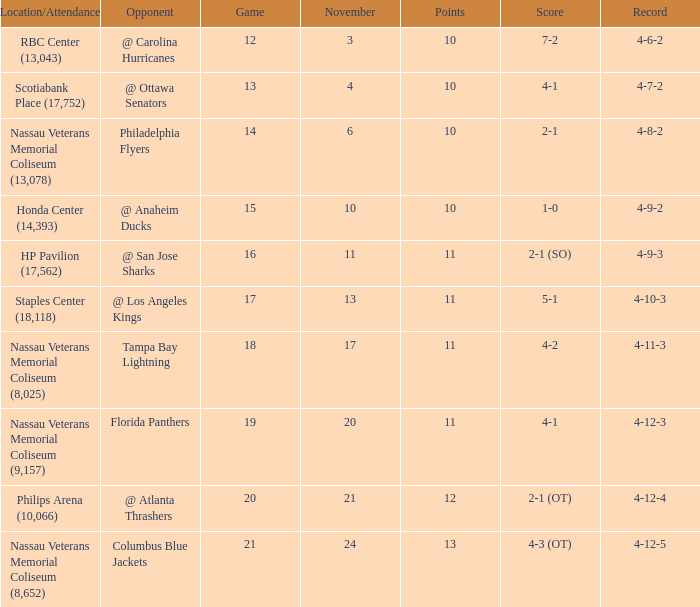What is every record for game 13? 4-7-2. 